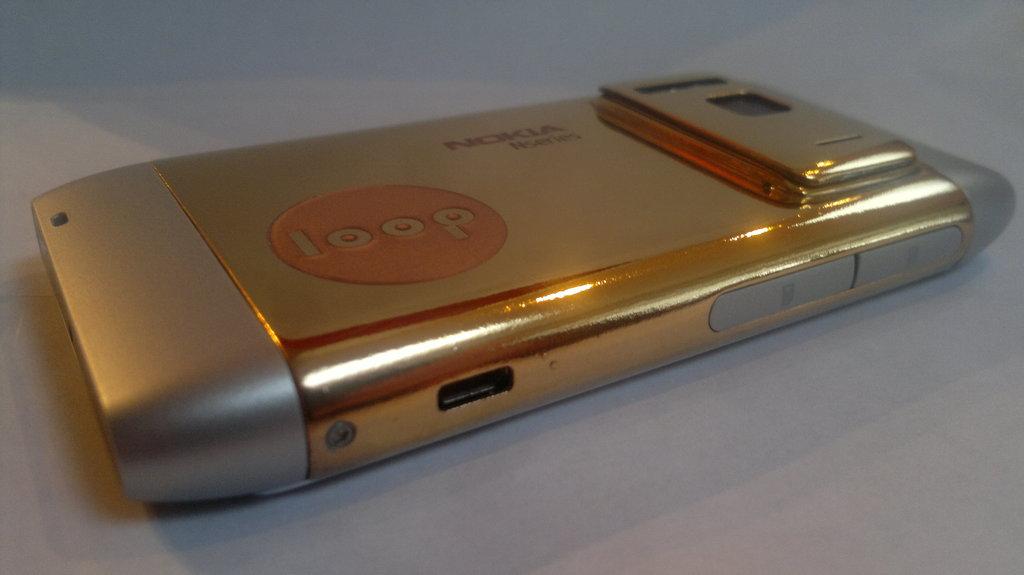What company made that?
Your answer should be very brief. Nokia. The brand of nokia is?
Give a very brief answer. Loop. 